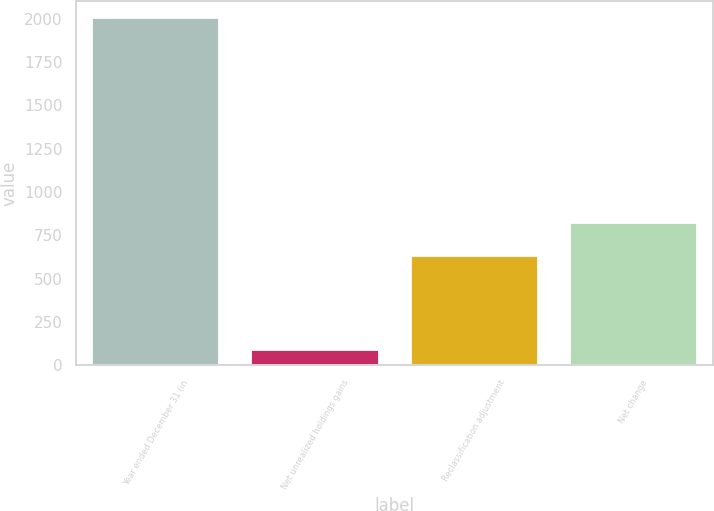<chart> <loc_0><loc_0><loc_500><loc_500><bar_chart><fcel>Year ended December 31 (in<fcel>Net unrealized holdings gains<fcel>Reclassification adjustment<fcel>Net change<nl><fcel>2003<fcel>86<fcel>631<fcel>822.7<nl></chart> 